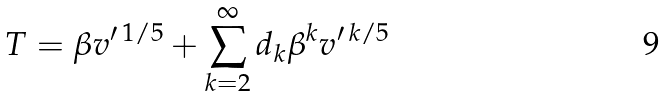<formula> <loc_0><loc_0><loc_500><loc_500>T = \beta v ^ { \prime \, { 1 / 5 } } + \sum _ { k = 2 } ^ { \infty } d _ { k } \beta ^ { k } v ^ { \prime \, { k / 5 } }</formula> 